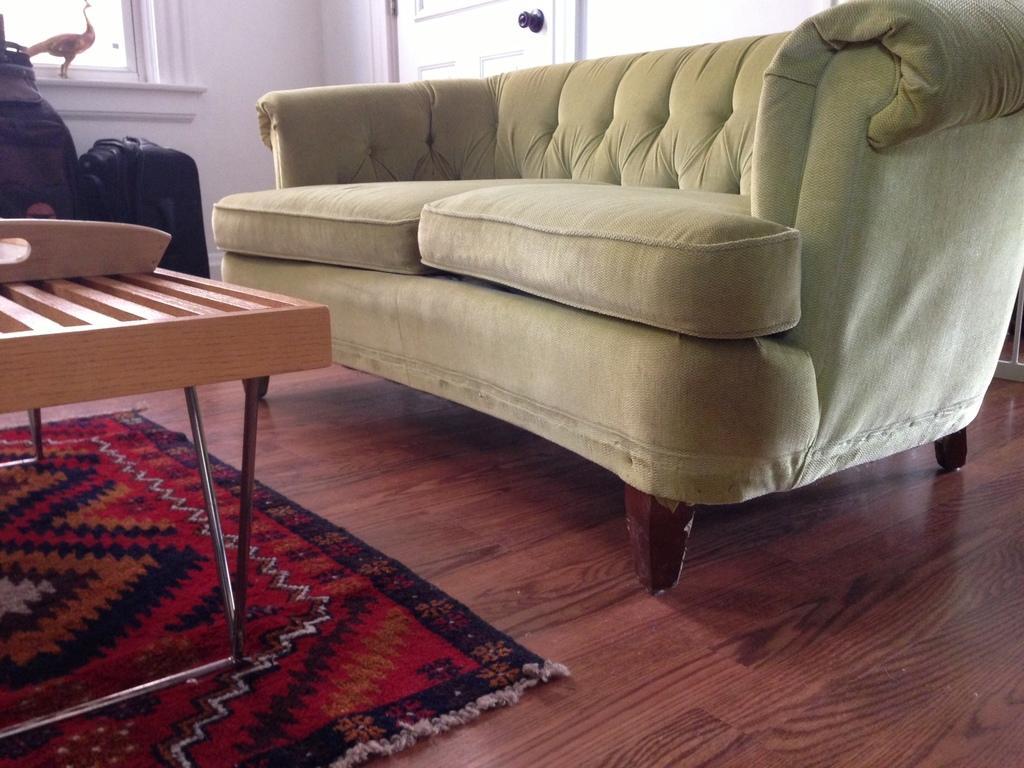Can you describe this image briefly? Sofa and a table beside a window with a door in the background. 